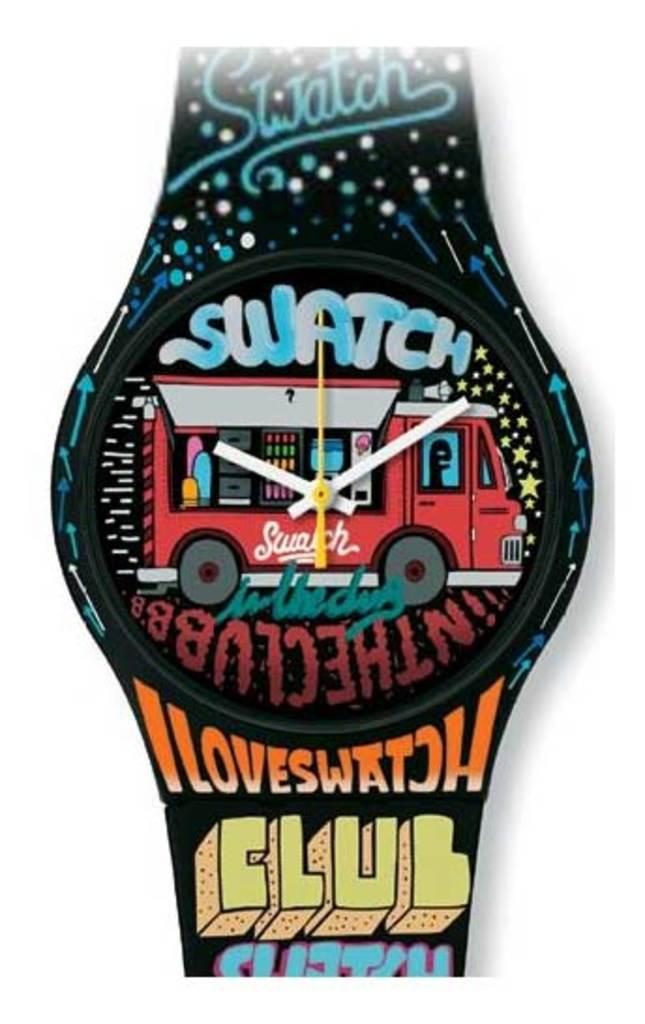<image>
Give a short and clear explanation of the subsequent image. A Swatch watch with a face plate showing a red food  truck. 